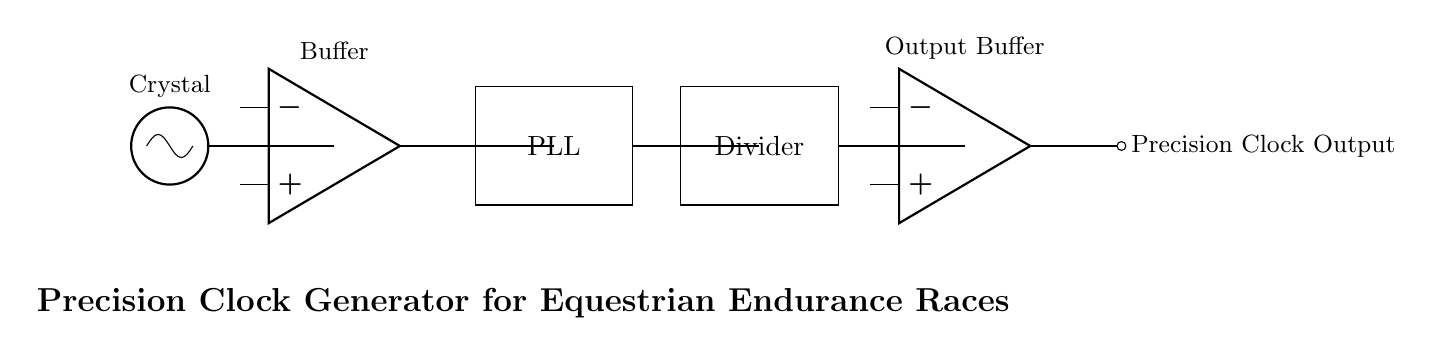What is the main component generating the clock signal? The main component generating the clock signal is the crystal oscillator, which is designated in the circuit diagram. It is located at the beginning of the circuit and is responsible for providing a stable frequency.
Answer: Crystal oscillator What type of component is used for buffering the signal? The buffering of the signal is performed using an operational amplifier, commonly abbreviated as op amp, which is indicated in the circuit. There are two instances of operational amplifiers in the diagram, one after the crystal oscillator and another after the divider.
Answer: Operational amplifier How many main functional blocks are in the circuit? The circuit includes four main functional blocks: the crystal oscillator, buffer, PLL, and divider. Each block processes the signal in a stepwise manner: the oscillator generates the clock, the buffer amplifies it, the PLL locks the frequency, and the divider reduces the frequency to a usable output.
Answer: Four What is the purpose of the PLL in the circuit? The purpose of the PLL, or Phase Locked Loop, in the circuit is to ensure that the output clock signal is synchronized with the input signal from the buffer. This synchronization is critical for maintaining high accuracy and stability in timekeeping during events like equestrian endurance races.
Answer: Synchronization What is the final output stage of this circuit? The final output stage of the circuit is an output buffer, which serves to deliver the precision clock output to external devices. The output buffer ensures that the signal can drive loads without degrading the quality of the clock signal generated earlier in the circuit.
Answer: Output buffer 